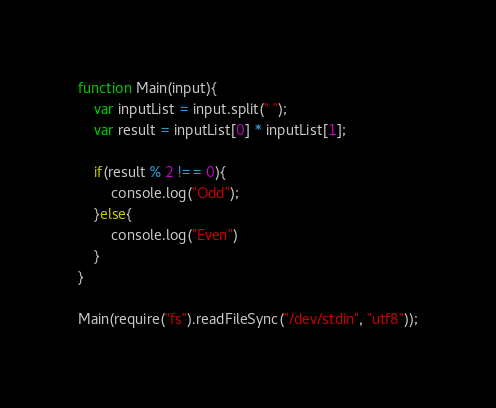Convert code to text. <code><loc_0><loc_0><loc_500><loc_500><_JavaScript_>function Main(input){
    var inputList = input.split(" ");
    var result = inputList[0] * inputList[1];

    if(result % 2 !== 0){
        console.log("Odd");
    }else{
        console.log("Even")
    }
}

Main(require("fs").readFileSync("/dev/stdin", "utf8"));</code> 